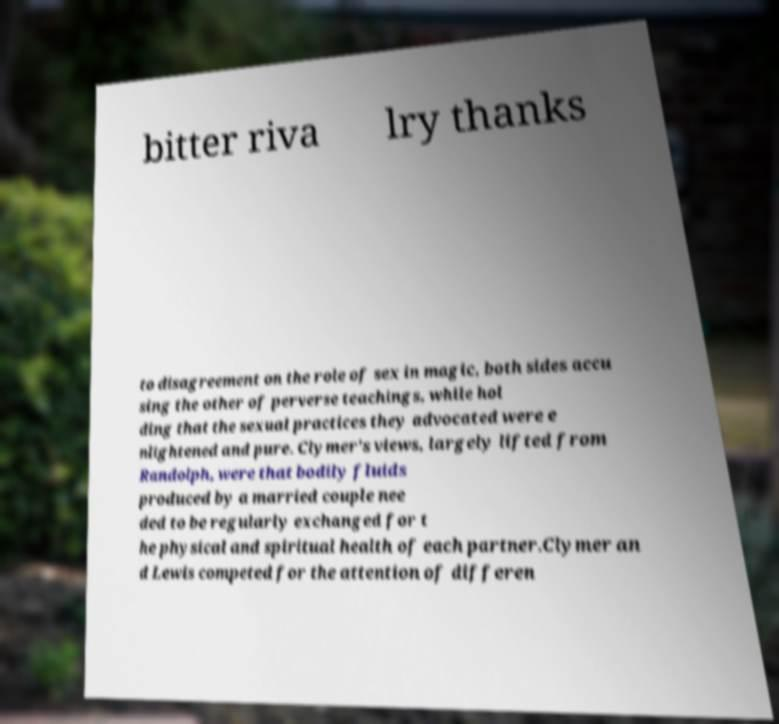What messages or text are displayed in this image? I need them in a readable, typed format. bitter riva lry thanks to disagreement on the role of sex in magic, both sides accu sing the other of perverse teachings, while hol ding that the sexual practices they advocated were e nlightened and pure. Clymer's views, largely lifted from Randolph, were that bodily fluids produced by a married couple nee ded to be regularly exchanged for t he physical and spiritual health of each partner.Clymer an d Lewis competed for the attention of differen 